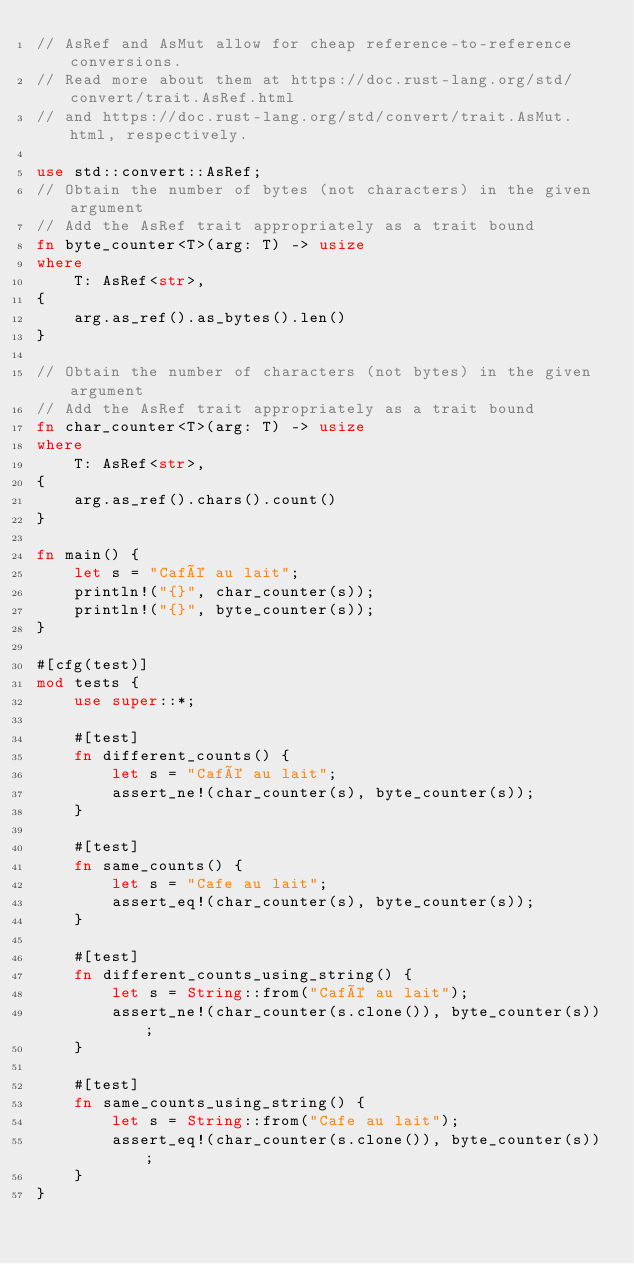Convert code to text. <code><loc_0><loc_0><loc_500><loc_500><_Rust_>// AsRef and AsMut allow for cheap reference-to-reference conversions.
// Read more about them at https://doc.rust-lang.org/std/convert/trait.AsRef.html
// and https://doc.rust-lang.org/std/convert/trait.AsMut.html, respectively.

use std::convert::AsRef;
// Obtain the number of bytes (not characters) in the given argument
// Add the AsRef trait appropriately as a trait bound
fn byte_counter<T>(arg: T) -> usize
where
    T: AsRef<str>,
{
    arg.as_ref().as_bytes().len()
}

// Obtain the number of characters (not bytes) in the given argument
// Add the AsRef trait appropriately as a trait bound
fn char_counter<T>(arg: T) -> usize
where
    T: AsRef<str>,
{
    arg.as_ref().chars().count()
}

fn main() {
    let s = "Café au lait";
    println!("{}", char_counter(s));
    println!("{}", byte_counter(s));
}

#[cfg(test)]
mod tests {
    use super::*;

    #[test]
    fn different_counts() {
        let s = "Café au lait";
        assert_ne!(char_counter(s), byte_counter(s));
    }

    #[test]
    fn same_counts() {
        let s = "Cafe au lait";
        assert_eq!(char_counter(s), byte_counter(s));
    }

    #[test]
    fn different_counts_using_string() {
        let s = String::from("Café au lait");
        assert_ne!(char_counter(s.clone()), byte_counter(s));
    }

    #[test]
    fn same_counts_using_string() {
        let s = String::from("Cafe au lait");
        assert_eq!(char_counter(s.clone()), byte_counter(s));
    }
}
</code> 